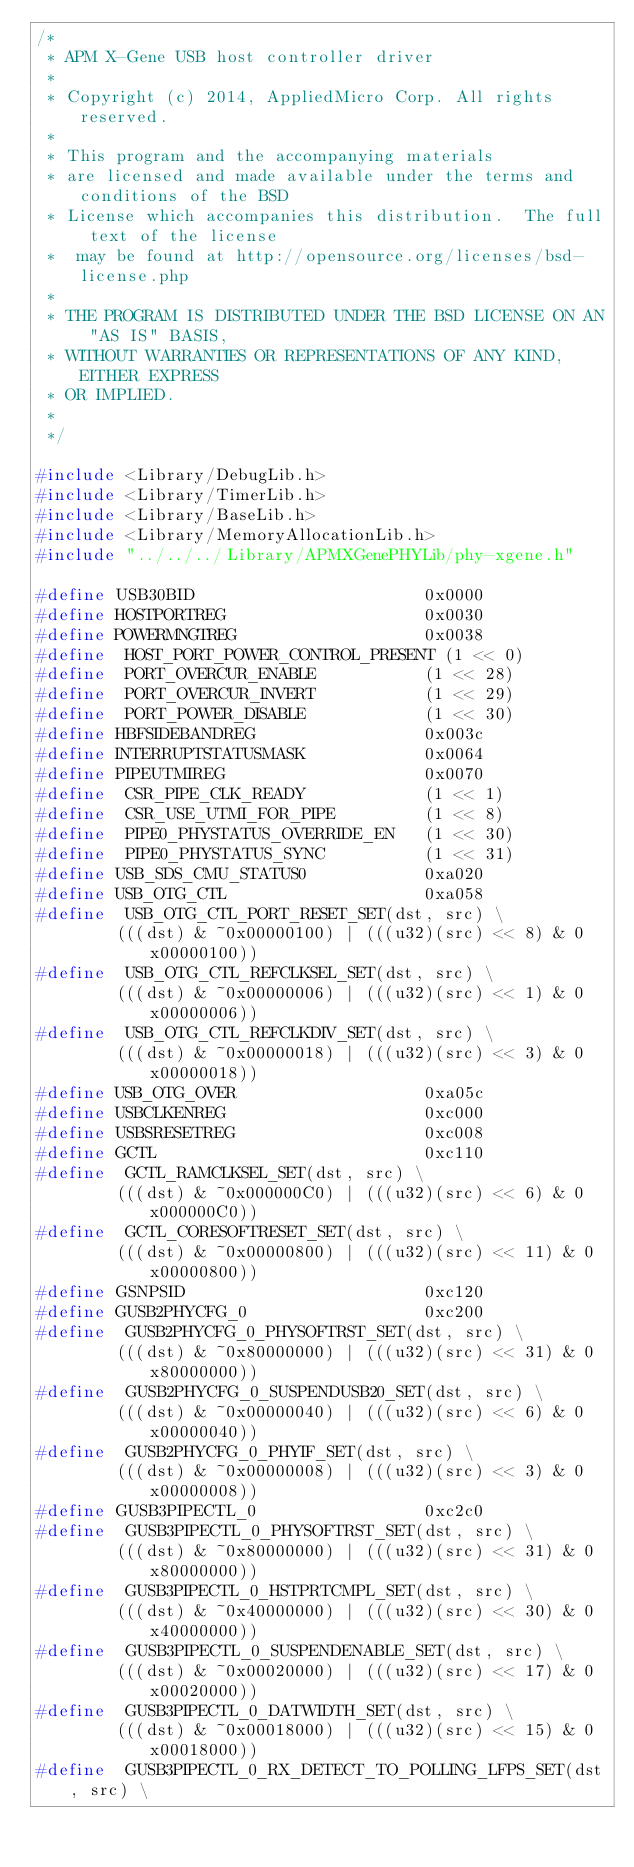Convert code to text. <code><loc_0><loc_0><loc_500><loc_500><_C_>/*
 * APM X-Gene USB host controller driver
 *
 * Copyright (c) 2014, AppliedMicro Corp. All rights reserved.
 *
 * This program and the accompanying materials
 * are licensed and made available under the terms and conditions of the BSD
 * License which accompanies this distribution.  The full text of the license
 *  may be found at http://opensource.org/licenses/bsd-license.php
 *
 * THE PROGRAM IS DISTRIBUTED UNDER THE BSD LICENSE ON AN "AS IS" BASIS,
 * WITHOUT WARRANTIES OR REPRESENTATIONS OF ANY KIND, EITHER EXPRESS
 * OR IMPLIED.
 *
 */

#include <Library/DebugLib.h>
#include <Library/TimerLib.h>
#include <Library/BaseLib.h>
#include <Library/MemoryAllocationLib.h>
#include "../../../Library/APMXGenePHYLib/phy-xgene.h"

#define USB30BID                       0x0000
#define HOSTPORTREG                    0x0030
#define POWERMNGTREG                   0x0038
#define  HOST_PORT_POWER_CONTROL_PRESENT (1 << 0)
#define  PORT_OVERCUR_ENABLE           (1 << 28)
#define  PORT_OVERCUR_INVERT           (1 << 29)
#define  PORT_POWER_DISABLE            (1 << 30)
#define HBFSIDEBANDREG                 0x003c
#define INTERRUPTSTATUSMASK            0x0064
#define PIPEUTMIREG                    0x0070
#define  CSR_PIPE_CLK_READY            (1 << 1)
#define  CSR_USE_UTMI_FOR_PIPE         (1 << 8)
#define  PIPE0_PHYSTATUS_OVERRIDE_EN   (1 << 30)
#define  PIPE0_PHYSTATUS_SYNC          (1 << 31)
#define USB_SDS_CMU_STATUS0            0xa020
#define USB_OTG_CTL                    0xa058
#define  USB_OTG_CTL_PORT_RESET_SET(dst, src) \
		(((dst) & ~0x00000100) | (((u32)(src) << 8) & 0x00000100))
#define  USB_OTG_CTL_REFCLKSEL_SET(dst, src) \
		(((dst) & ~0x00000006) | (((u32)(src) << 1) & 0x00000006))
#define  USB_OTG_CTL_REFCLKDIV_SET(dst, src) \
		(((dst) & ~0x00000018) | (((u32)(src) << 3) & 0x00000018))
#define USB_OTG_OVER                   0xa05c
#define USBCLKENREG                    0xc000
#define USBSRESETREG                   0xc008
#define GCTL                           0xc110
#define  GCTL_RAMCLKSEL_SET(dst, src) \
		(((dst) & ~0x000000C0) | (((u32)(src) << 6) & 0x000000C0))
#define  GCTL_CORESOFTRESET_SET(dst, src) \
		(((dst) & ~0x00000800) | (((u32)(src) << 11) & 0x00000800))
#define GSNPSID                        0xc120
#define GUSB2PHYCFG_0                  0xc200
#define  GUSB2PHYCFG_0_PHYSOFTRST_SET(dst, src) \
		(((dst) & ~0x80000000) | (((u32)(src) << 31) & 0x80000000))
#define  GUSB2PHYCFG_0_SUSPENDUSB20_SET(dst, src) \
		(((dst) & ~0x00000040) | (((u32)(src) << 6) & 0x00000040))
#define  GUSB2PHYCFG_0_PHYIF_SET(dst, src) \
		(((dst) & ~0x00000008) | (((u32)(src) << 3) & 0x00000008))
#define GUSB3PIPECTL_0                 0xc2c0
#define  GUSB3PIPECTL_0_PHYSOFTRST_SET(dst, src) \
		(((dst) & ~0x80000000) | (((u32)(src) << 31) & 0x80000000))
#define  GUSB3PIPECTL_0_HSTPRTCMPL_SET(dst, src) \
		(((dst) & ~0x40000000) | (((u32)(src) << 30) & 0x40000000))
#define  GUSB3PIPECTL_0_SUSPENDENABLE_SET(dst, src) \
		(((dst) & ~0x00020000) | (((u32)(src) << 17) & 0x00020000))
#define  GUSB3PIPECTL_0_DATWIDTH_SET(dst, src) \
		(((dst) & ~0x00018000) | (((u32)(src) << 15) & 0x00018000))
#define  GUSB3PIPECTL_0_RX_DETECT_TO_POLLING_LFPS_SET(dst, src) \</code> 